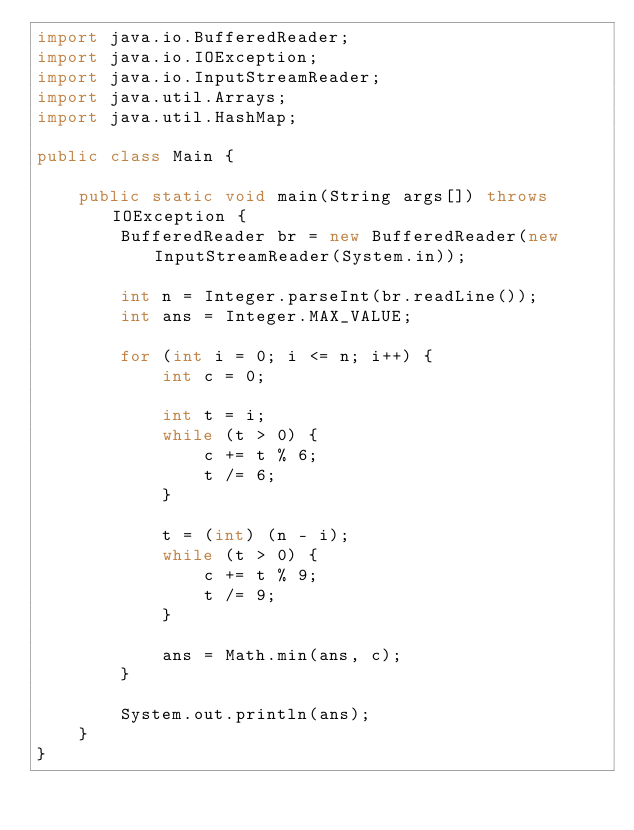Convert code to text. <code><loc_0><loc_0><loc_500><loc_500><_Java_>import java.io.BufferedReader;
import java.io.IOException;
import java.io.InputStreamReader;
import java.util.Arrays;
import java.util.HashMap;

public class Main {

	public static void main(String args[]) throws IOException {
		BufferedReader br = new BufferedReader(new InputStreamReader(System.in));

		int n = Integer.parseInt(br.readLine());
		int ans = Integer.MAX_VALUE;

		for (int i = 0; i <= n; i++) {
			int c = 0;

			int t = i;
			while (t > 0) {
				c += t % 6;
				t /= 6;
			}

			t = (int) (n - i);
			while (t > 0) {
				c += t % 9;
				t /= 9;
			}

			ans = Math.min(ans, c);
		}

		System.out.println(ans);
	}
}</code> 